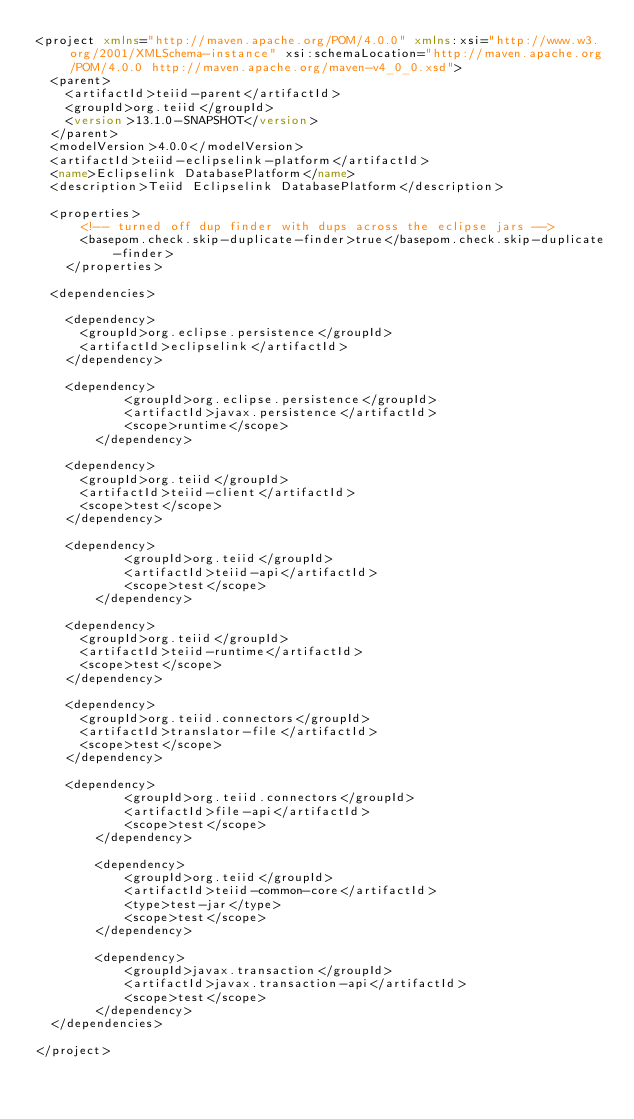Convert code to text. <code><loc_0><loc_0><loc_500><loc_500><_XML_><project xmlns="http://maven.apache.org/POM/4.0.0" xmlns:xsi="http://www.w3.org/2001/XMLSchema-instance" xsi:schemaLocation="http://maven.apache.org/POM/4.0.0 http://maven.apache.org/maven-v4_0_0.xsd">
	<parent>
		<artifactId>teiid-parent</artifactId>
		<groupId>org.teiid</groupId>
		<version>13.1.0-SNAPSHOT</version>
	</parent>
	<modelVersion>4.0.0</modelVersion>
	<artifactId>teiid-eclipselink-platform</artifactId>
	<name>Eclipselink DatabasePlatform</name>
	<description>Teiid Eclipselink DatabasePlatform</description>

	<properties>
	    <!-- turned off dup finder with dups across the eclipse jars -->
	    <basepom.check.skip-duplicate-finder>true</basepom.check.skip-duplicate-finder>
    </properties>

	<dependencies>
	
		<dependency>
			<groupId>org.eclipse.persistence</groupId>
			<artifactId>eclipselink</artifactId>
		</dependency>
		
		<dependency>
            <groupId>org.eclipse.persistence</groupId>
            <artifactId>javax.persistence</artifactId>
            <scope>runtime</scope>
        </dependency>
        
		<dependency>
			<groupId>org.teiid</groupId>
			<artifactId>teiid-client</artifactId>
			<scope>test</scope>
		</dependency>
		
		<dependency>
            <groupId>org.teiid</groupId>
            <artifactId>teiid-api</artifactId>
            <scope>test</scope>
        </dependency>
		
		<dependency>
			<groupId>org.teiid</groupId>
			<artifactId>teiid-runtime</artifactId>
			<scope>test</scope>
		</dependency>
		
		<dependency>
			<groupId>org.teiid.connectors</groupId>
			<artifactId>translator-file</artifactId>
			<scope>test</scope>
		</dependency>
		
		<dependency>
            <groupId>org.teiid.connectors</groupId>
            <artifactId>file-api</artifactId>
            <scope>test</scope>
        </dependency>

        <dependency>
            <groupId>org.teiid</groupId>
            <artifactId>teiid-common-core</artifactId>
            <type>test-jar</type>
            <scope>test</scope>
        </dependency>    
		
        <dependency>
            <groupId>javax.transaction</groupId>
            <artifactId>javax.transaction-api</artifactId>
            <scope>test</scope>
        </dependency>
	</dependencies>
	
</project>
</code> 